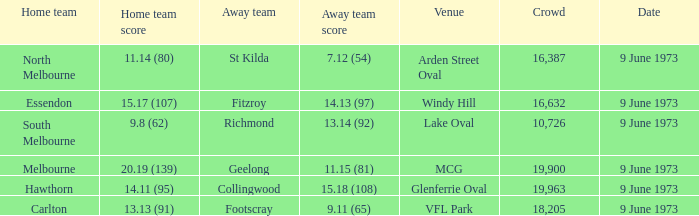What was North Melbourne's score as the home team? 11.14 (80). 